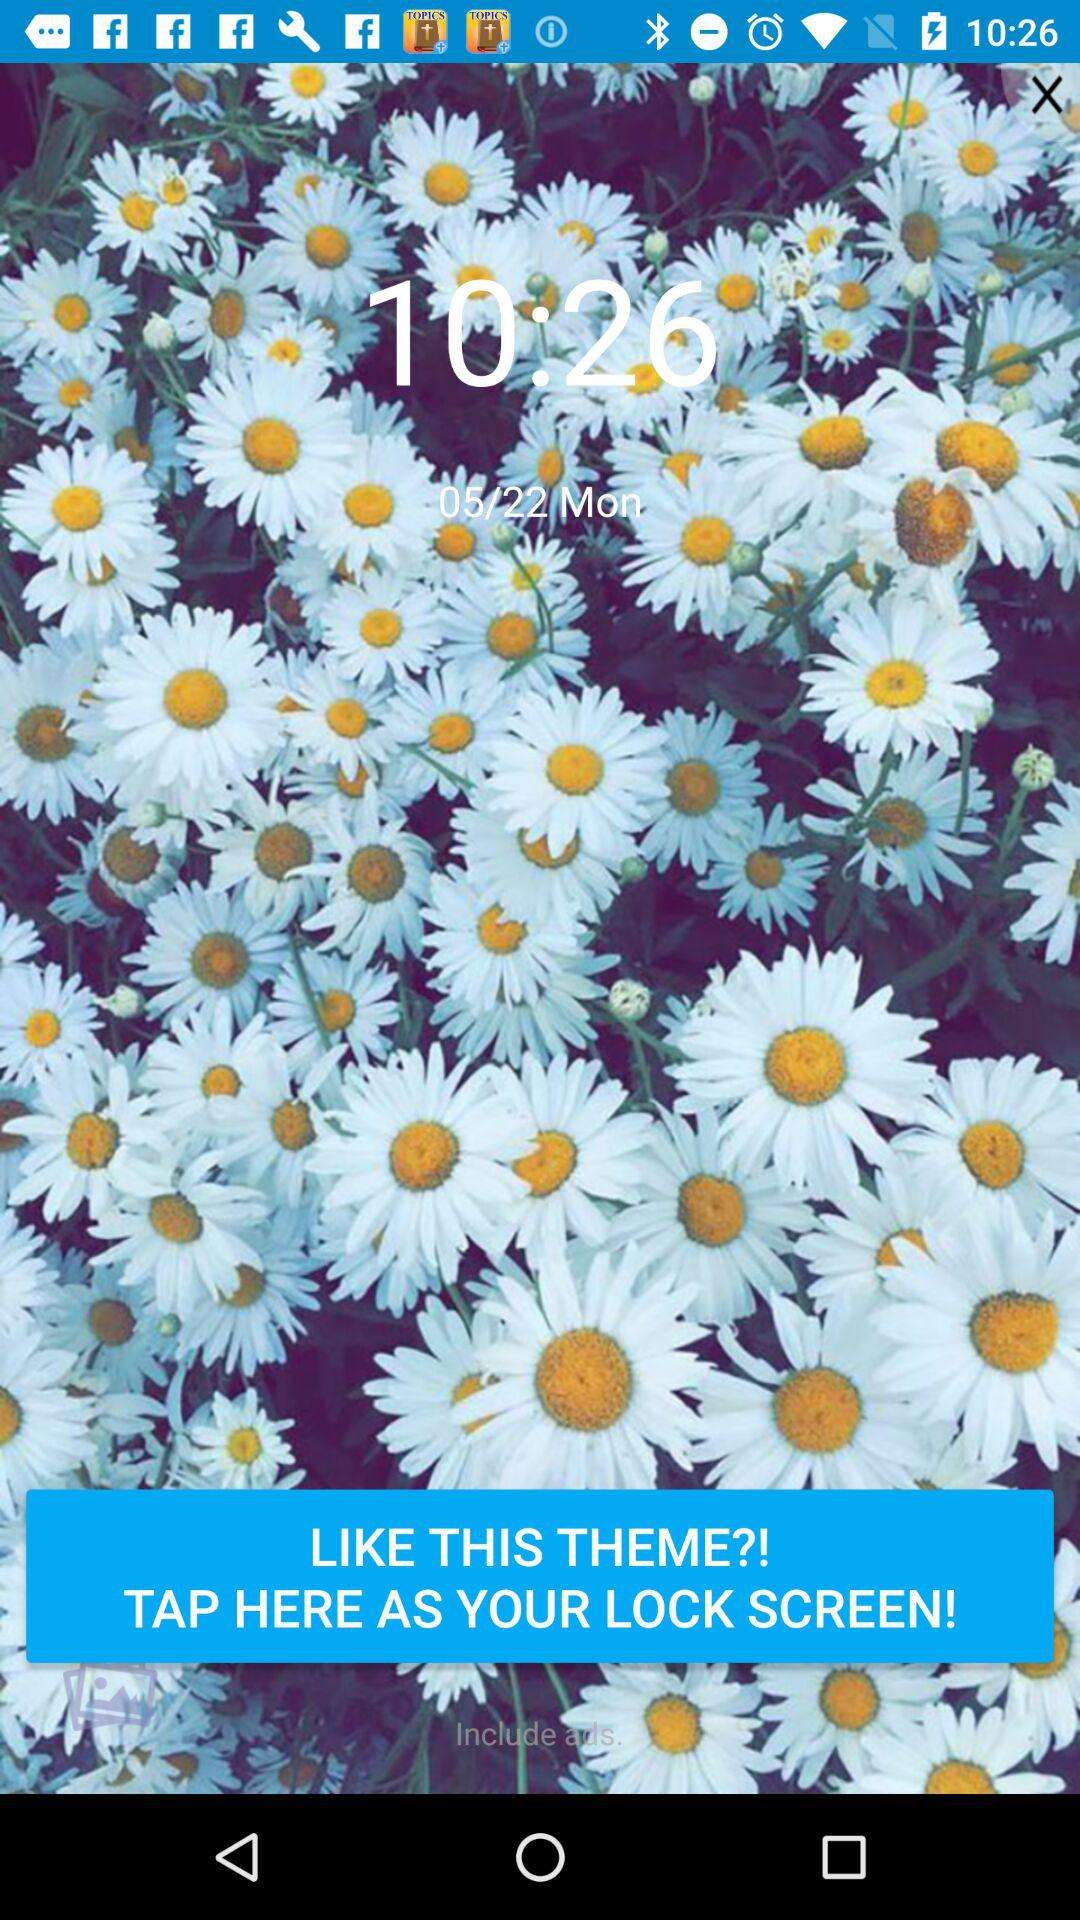What is the given date in the wallpaper? The date is Monday, May 22. 